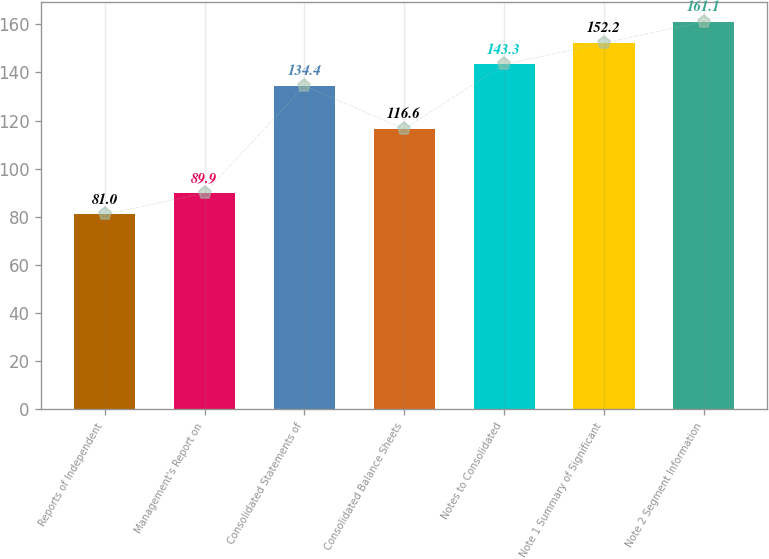Convert chart to OTSL. <chart><loc_0><loc_0><loc_500><loc_500><bar_chart><fcel>Reports of Independent<fcel>Management's Report on<fcel>Consolidated Statements of<fcel>Consolidated Balance Sheets<fcel>Notes to Consolidated<fcel>Note 1 Summary of Significant<fcel>Note 2 Segment Information<nl><fcel>81<fcel>89.9<fcel>134.4<fcel>116.6<fcel>143.3<fcel>152.2<fcel>161.1<nl></chart> 